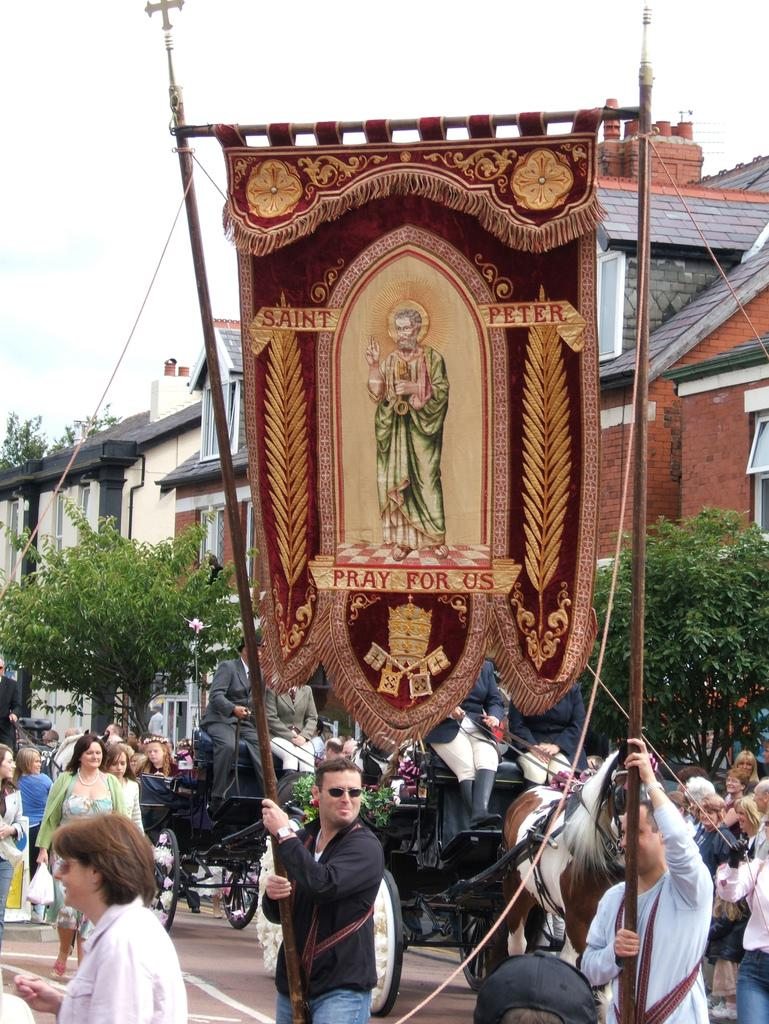What type of structures can be seen in the image? There are buildings in the image. What are the people in the image doing? There are people walking on the road and people seated on a chariot. What mode of transportation is present in the image? There is a chariot in the image. What else can be seen in the image besides the buildings and people? There are frozen objects (freeze) in the image. What type of board is being used by the people in the image? There is no board present in the image. Can you see any rays in the image? There are no rays visible in the image. 